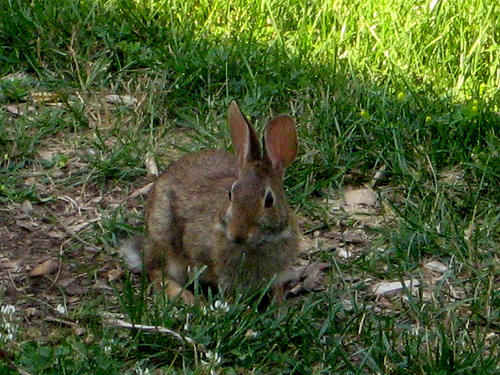<image>
Is there a rabbit on the grass? Yes. Looking at the image, I can see the rabbit is positioned on top of the grass, with the grass providing support. 